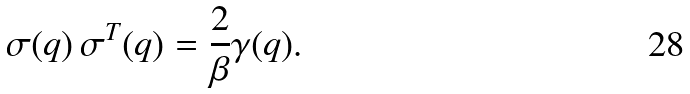Convert formula to latex. <formula><loc_0><loc_0><loc_500><loc_500>\sigma ( q ) \, \sigma ^ { T } ( q ) = \frac { 2 } { \beta } \gamma ( q ) .</formula> 